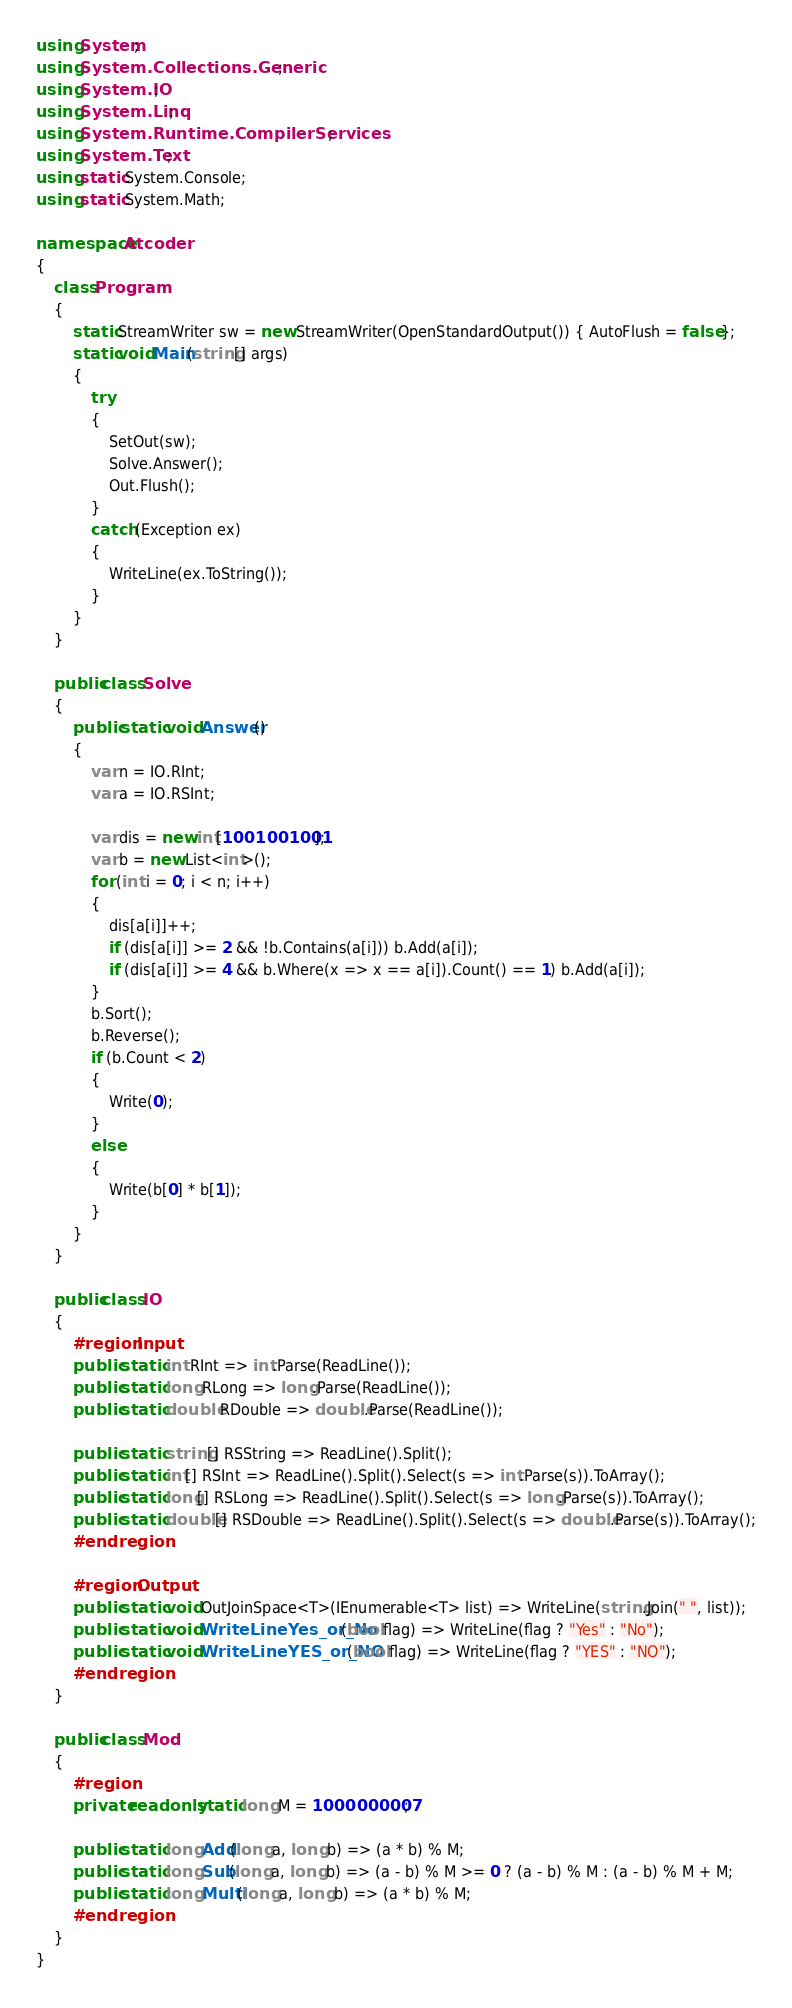<code> <loc_0><loc_0><loc_500><loc_500><_C#_>using System;
using System.Collections.Generic;
using System.IO;
using System.Linq;
using System.Runtime.CompilerServices;
using System.Text;
using static System.Console;
using static System.Math;

namespace Atcoder
{
    class Program
    {
        static StreamWriter sw = new StreamWriter(OpenStandardOutput()) { AutoFlush = false };
        static void Main(string[] args)
        {
            try
            {
                SetOut(sw);
                Solve.Answer();
                Out.Flush();
            }
            catch (Exception ex)
            {
                WriteLine(ex.ToString());
            }
        }
    }

    public class Solve
    {
        public static void Answer()
        {
            var n = IO.RInt;
            var a = IO.RSInt;

            var dis = new int[1001001001];
            var b = new List<int>();
            for (int i = 0; i < n; i++)
            {
                dis[a[i]]++;
                if (dis[a[i]] >= 2 && !b.Contains(a[i])) b.Add(a[i]);
                if (dis[a[i]] >= 4 && b.Where(x => x == a[i]).Count() == 1) b.Add(a[i]);
            }
            b.Sort();
            b.Reverse();
            if (b.Count < 2)
            {
                Write(0);
            }
            else
            {
                Write(b[0] * b[1]);
            }
        }
    }

    public class IO
    {
        #region Input
        public static int RInt => int.Parse(ReadLine());
        public static long RLong => long.Parse(ReadLine());
        public static double RDouble => double.Parse(ReadLine());

        public static string[] RSString => ReadLine().Split();
        public static int[] RSInt => ReadLine().Split().Select(s => int.Parse(s)).ToArray();
        public static long[] RSLong => ReadLine().Split().Select(s => long.Parse(s)).ToArray();
        public static double[] RSDouble => ReadLine().Split().Select(s => double.Parse(s)).ToArray();
        #endregion

        #region Output
        public static void OutJoinSpace<T>(IEnumerable<T> list) => WriteLine(string.Join(" ", list));
        public static void WriteLineYes_or_No(bool flag) => WriteLine(flag ? "Yes" : "No");
        public static void WriteLineYES_or_NO(bool flag) => WriteLine(flag ? "YES" : "NO");
        #endregion
    }

    public class Mod
    {
        #region
        private readonly static long M = 1000000007;

        public static long Add(long a, long b) => (a * b) % M;
        public static long Sub(long a, long b) => (a - b) % M >= 0 ? (a - b) % M : (a - b) % M + M;
        public static long Multi(long a, long b) => (a * b) % M;
        #endregion
    }
}</code> 